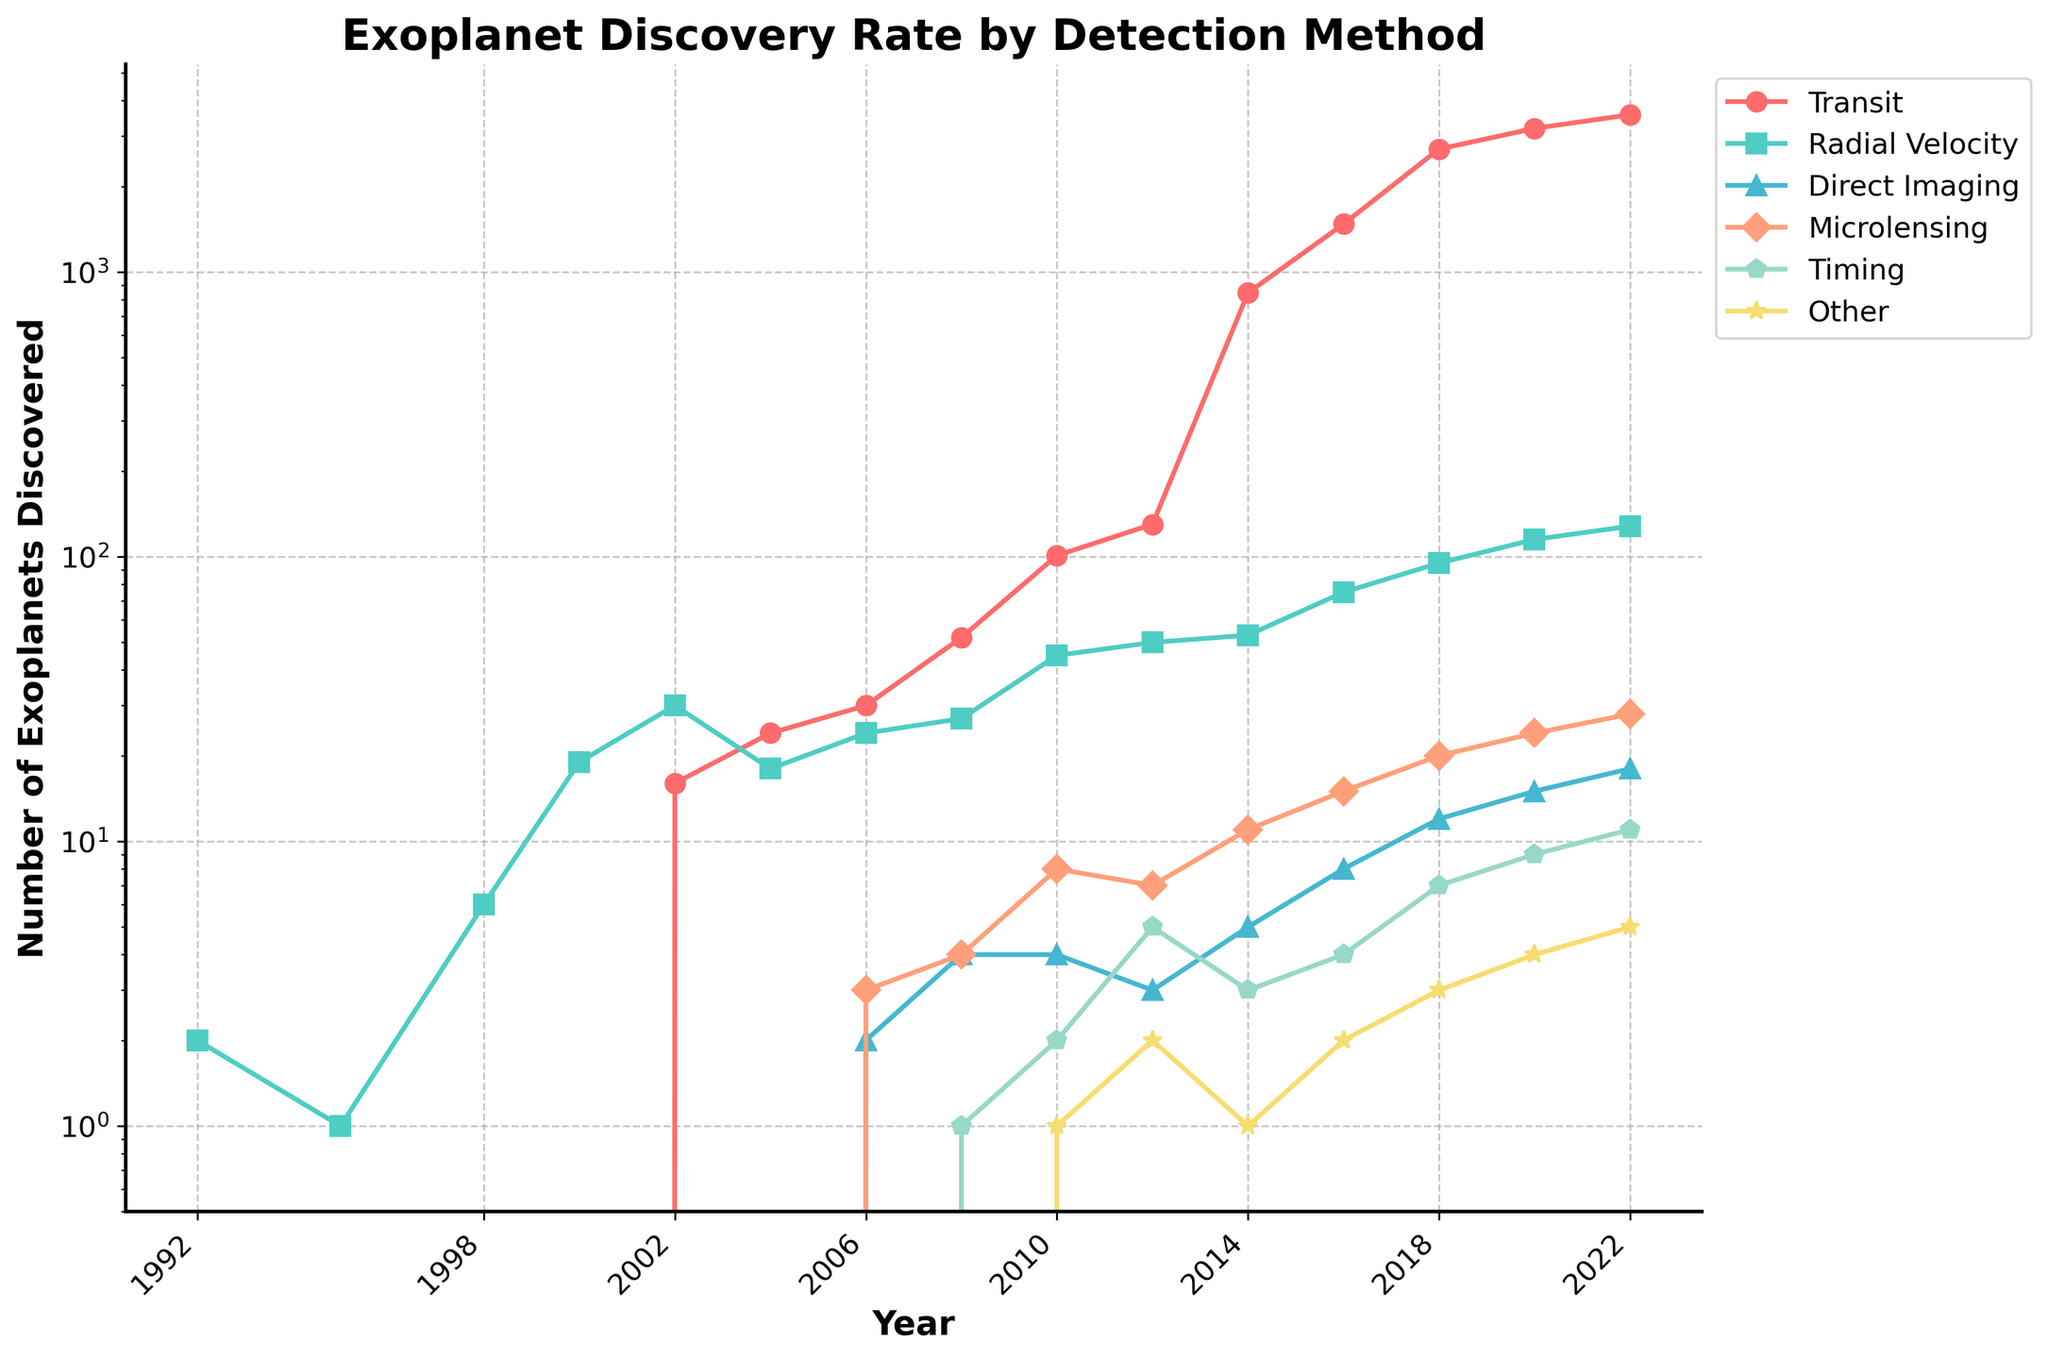What detection method saw the highest number of discoveries in 2022? Look at the line chart for 2022 and identify which detection method has the highest point. According to the chart, 'Transit' has the highest point in 2022.
Answer: Transit How many more exoplanets were discovered by the Transit method in 2018 compared to 2014? Identify and subtract the numbers for the Transit method in 2018 and 2014: 2705 (2018) - 845 (2014) = 1860.
Answer: 1860 Which detection method shows the greatest growth rate between 2010 and 2020? Compare the differences in exoplanet discoveries for each method between 2010 and 2020. The Transit method grows from 101 in 2010 to 3197 in 2020.
Answer: Transit In which year did the Transit method's discoveries first surpass 1000? Identify the first year in which the number for the Transit method exceeds 1000. According to the chart, it's 2016.
Answer: 2016 By how many did the number of exoplanets discovered using Microlensing increase from 2006 to 2022? Subtract the Microlensing discoveries in 2006 from those in 2022: 28 (2022) - 3 (2006) = 25.
Answer: 25 Which detection method consistently showed at least some discoveries every year between 2000 and 2022? Look at the lines for each detection method and check if any method has data points for each year. The Radial Velocity method has consistent data points.
Answer: Radial Velocity In 2008, which detection method contributed the least to the total number of discoveries, and what was its count? Identify the method with the lowest point in 2008 and note the count. According to the chart, it's Timing with 1 discovery.
Answer: Timing, 1 What is the general trend of exoplanet discoveries using the Radial Velocity method from 1992 to 2022? Observe the overall pattern for the Radial Velocity method line. It generally increases but at a slower rate compared to the Transit method.
Answer: Increasing Which method had a higher number of discoveries in 2014—Microlensing or Direct Imaging? Compare the points for Microlensing and Direct Imaging in 2014: 11 for Microlensing and 5 for Direct Imaging.
Answer: Microlensing 